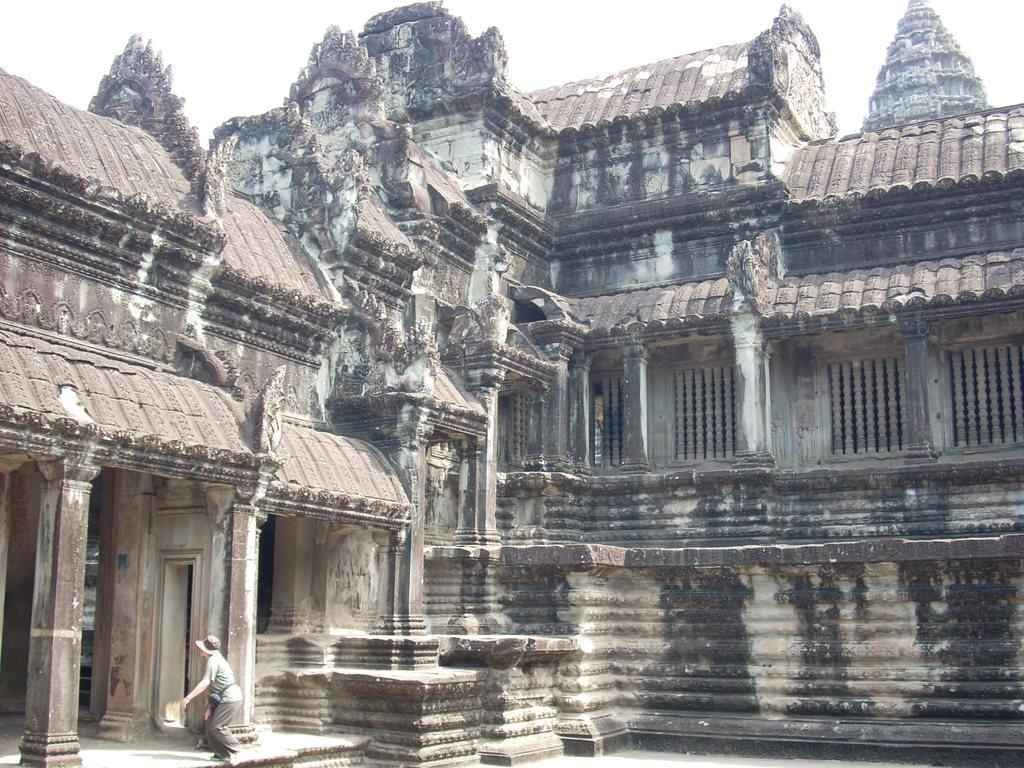What is the main structure in the image? There is a building in the image. Can you describe any people or figures in the image? There is a person standing on the left side of the image. What type of wine is the person holding in the image? There is no wine present in the image; the person is not holding anything. 